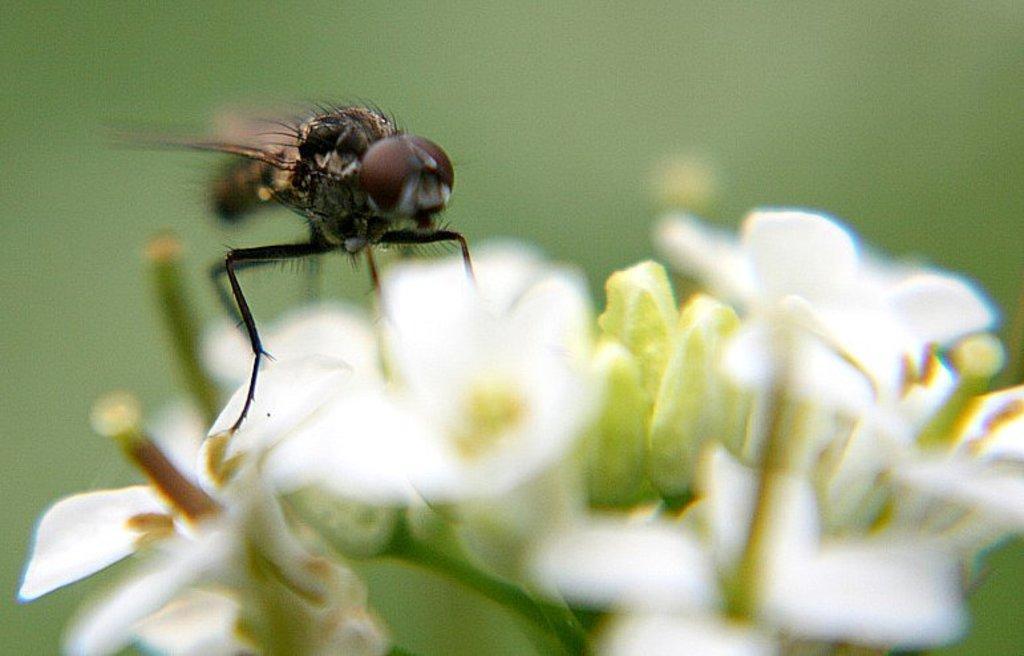Please provide a concise description of this image. In this picture we can observe an insect on the flower. The flower is in white color. In the background it is completely blur. 